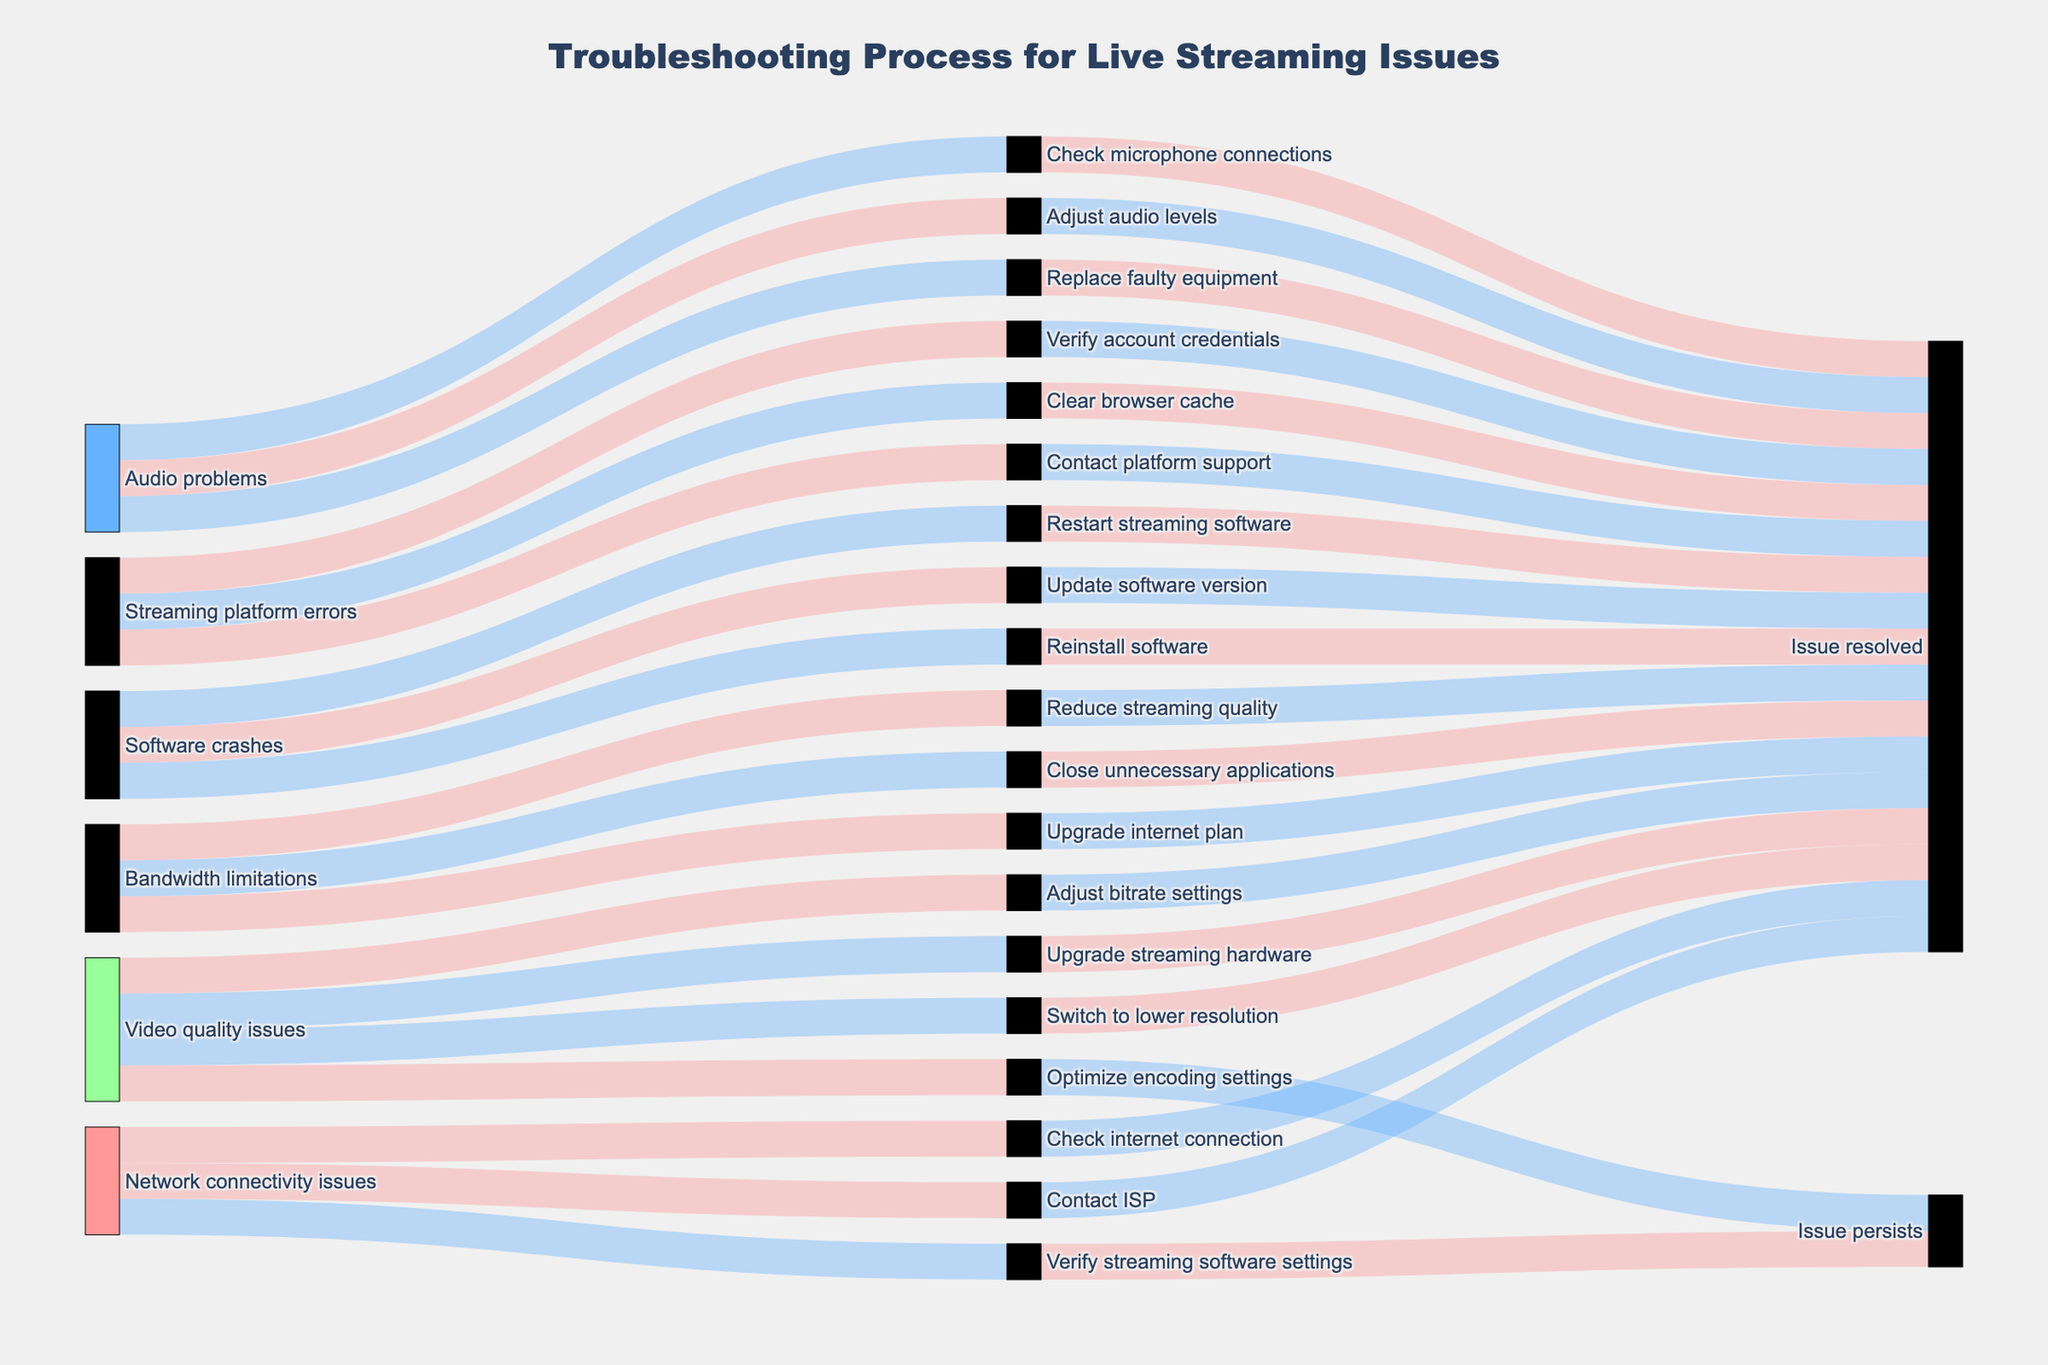What is the title of the Sankey diagram? Look at the top of the diagram where the title is placed. The title provides a concise summary of what the diagram illustrates.
Answer: Troubleshooting Process for Live Streaming Issues How many unique sources of issues are shown in the diagram? Identify all the different issue sources represented. Each source should be unique and distinctly labeled.
Answer: 5 Which issue source has the most diverse resolution steps? Count the number of unique resolution steps associated with each issue source. The source with the highest count has the most diverse resolution steps.
Answer: Video quality issues Compare the outcomes of "Network connectivity issues" and "Audio problems". Which one has more instances where the issue persists? Identify the outcomes linked to both "Network connectivity issues" and "Audio problems", then count the instances where the outcome is "Issue persists".
Answer: Network connectivity issues If the issue source is "Bandwidth limitations", what are the possible resolution steps? Follow the flow from the "Bandwidth limitations" issue source to its associated resolution steps. List all the steps identified.
Answer: Reduce streaming quality, Close unnecessary applications, Upgrade internet plan How many steps lead to an outcome of "Issue resolved"? Count the number of steps that are directly connected to the outcome "Issue resolved".
Answer: 15 Can you trace the path for resolving "Software crashes"? Discuss the steps and outcomes. Identify the starting point "Software crashes", then follow each pathway to the associated steps and their respective outcomes. Detail each path taken.
Answer: Steps: Restart streaming software, Update software version, Reinstall software. Outcomes: Issue resolved for all steps Which source of issue has no resolution step leading to "Issue persists"? Identify sources of issues and check their pathways. The source where all paths lead to "Issue resolved" has no "Issue persists" outcomes.
Answer: Bandwidth limitations For "Streaming platform errors", list the steps that lead to the resolution. Start from "Streaming platform errors" and trace all pathways to the resolution steps. List all such steps.
Answer: Verify account credentials, Clear browser cache, Contact platform support What is a common resolution outcome for "Video quality issues"? Trace the paths from "Video quality issues" to their outcomes and identify the outcome that appears most frequently.
Answer: Issue resolved 